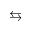<formula> <loc_0><loc_0><loc_500><loc_500>\leftrightarrow s</formula> 